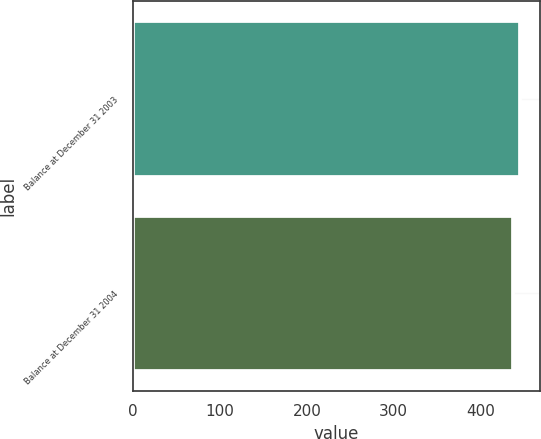Convert chart to OTSL. <chart><loc_0><loc_0><loc_500><loc_500><bar_chart><fcel>Balance at December 31 2003<fcel>Balance at December 31 2004<nl><fcel>446<fcel>438<nl></chart> 